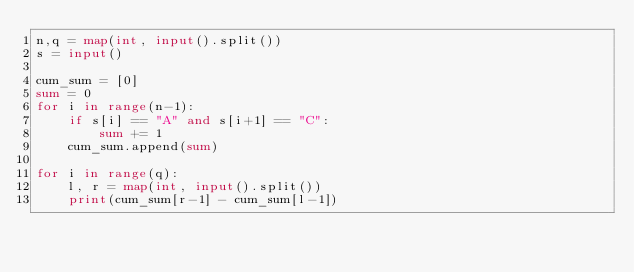<code> <loc_0><loc_0><loc_500><loc_500><_Python_>n,q = map(int, input().split())
s = input()

cum_sum = [0]
sum = 0
for i in range(n-1):
    if s[i] == "A" and s[i+1] == "C":
        sum += 1
    cum_sum.append(sum)

for i in range(q):
    l, r = map(int, input().split())
    print(cum_sum[r-1] - cum_sum[l-1])
</code> 